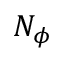Convert formula to latex. <formula><loc_0><loc_0><loc_500><loc_500>N _ { \phi }</formula> 